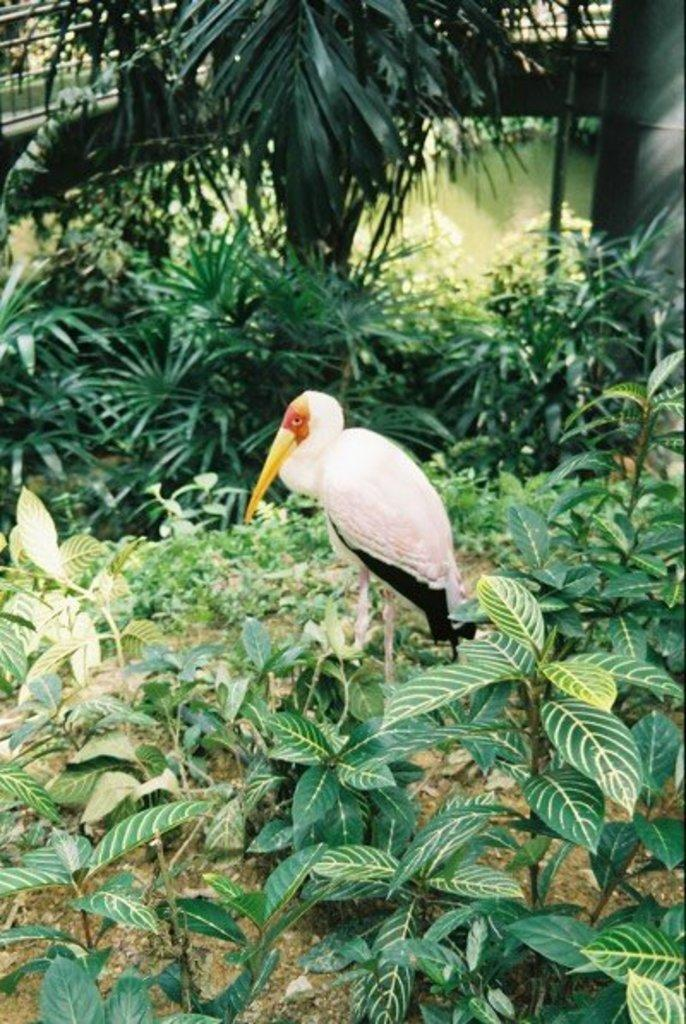What type of animal can be seen in the image? There is a bird in the image. What other living organisms are present in the image? There are plants and trees visible in the image. What natural element can be seen in the image? There is water visible in the image. Are there any man-made structures in the image? Yes, there is a pillar and a bridge in the image. What type of stamp can be seen on the bird's wing in the image? There is no stamp visible on the bird's wing in the image. Can you hear the bird laughing in the image? Birds do not laugh, and there is no sound associated with the image. 